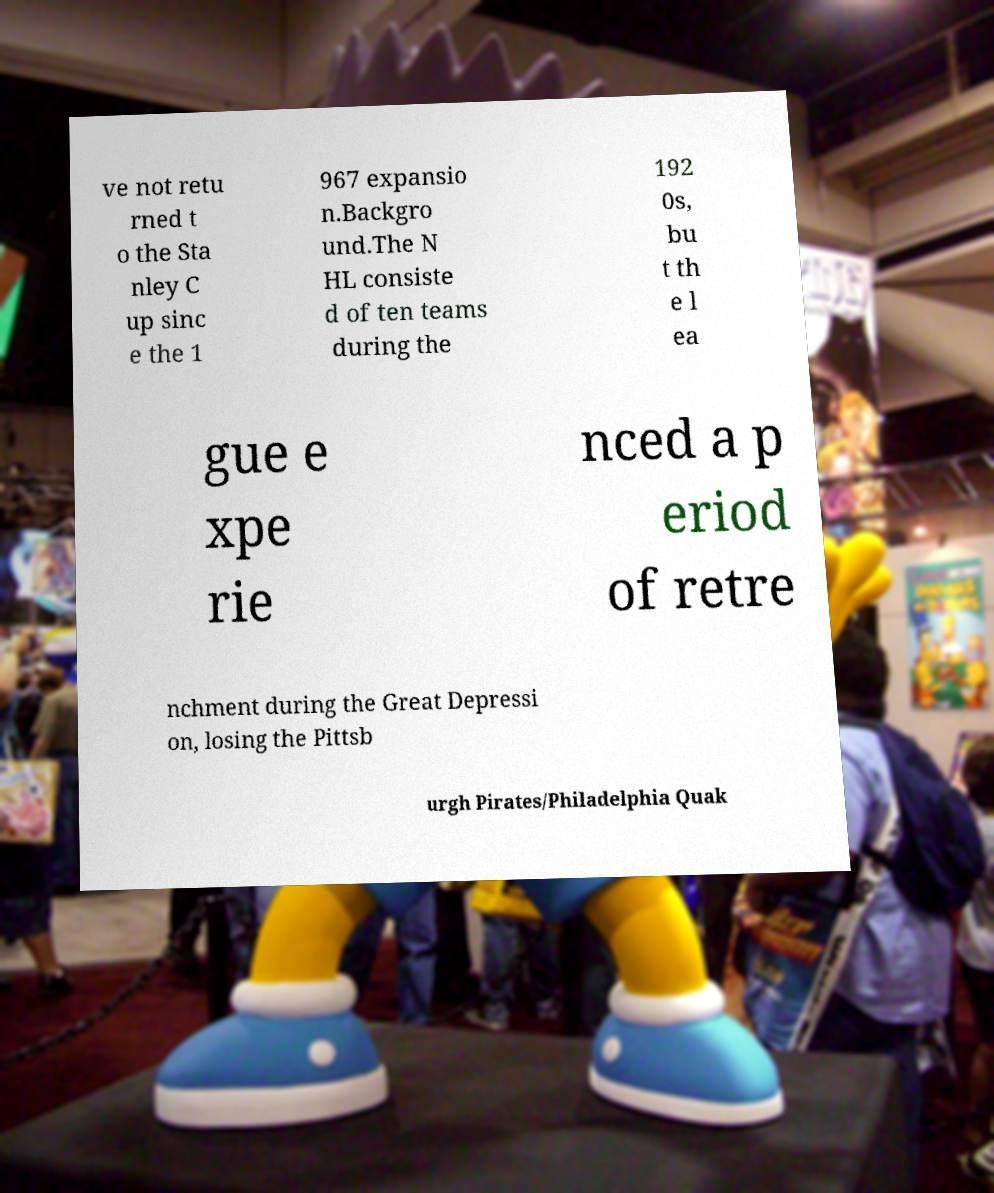I need the written content from this picture converted into text. Can you do that? ve not retu rned t o the Sta nley C up sinc e the 1 967 expansio n.Backgro und.The N HL consiste d of ten teams during the 192 0s, bu t th e l ea gue e xpe rie nced a p eriod of retre nchment during the Great Depressi on, losing the Pittsb urgh Pirates/Philadelphia Quak 